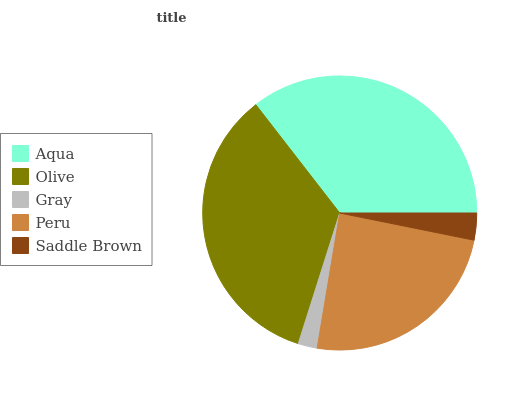Is Gray the minimum?
Answer yes or no. Yes. Is Aqua the maximum?
Answer yes or no. Yes. Is Olive the minimum?
Answer yes or no. No. Is Olive the maximum?
Answer yes or no. No. Is Aqua greater than Olive?
Answer yes or no. Yes. Is Olive less than Aqua?
Answer yes or no. Yes. Is Olive greater than Aqua?
Answer yes or no. No. Is Aqua less than Olive?
Answer yes or no. No. Is Peru the high median?
Answer yes or no. Yes. Is Peru the low median?
Answer yes or no. Yes. Is Saddle Brown the high median?
Answer yes or no. No. Is Aqua the low median?
Answer yes or no. No. 